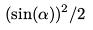Convert formula to latex. <formula><loc_0><loc_0><loc_500><loc_500>( \sin ( \alpha ) ) ^ { 2 } / 2</formula> 